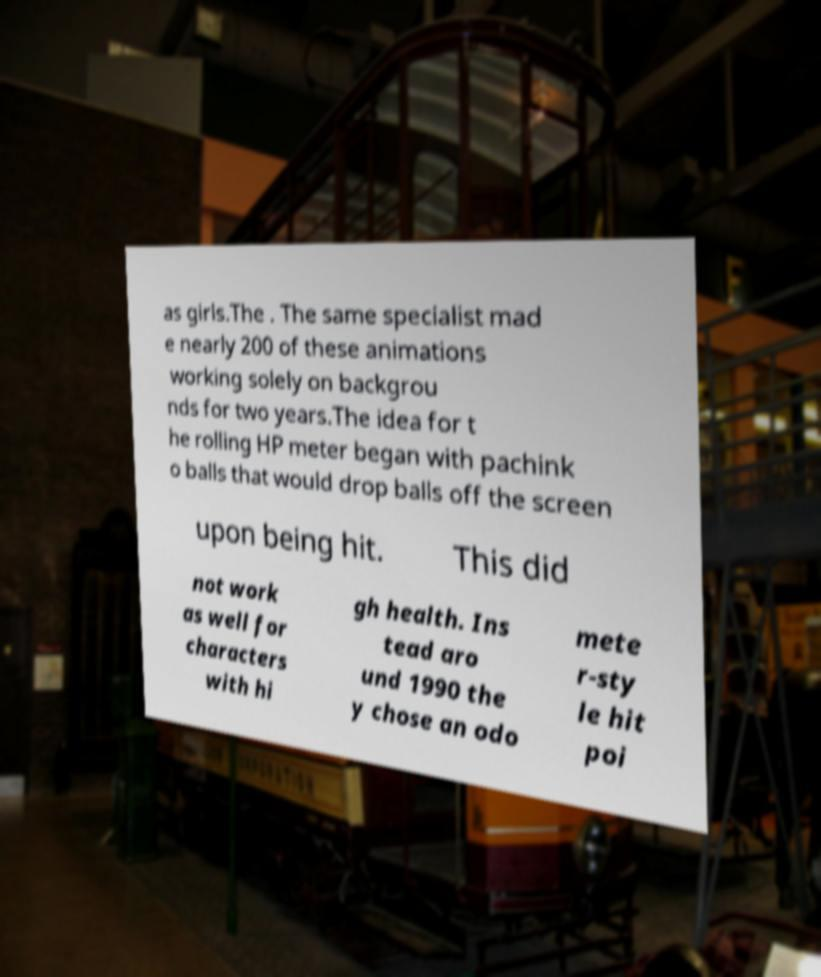What messages or text are displayed in this image? I need them in a readable, typed format. as girls.The . The same specialist mad e nearly 200 of these animations working solely on backgrou nds for two years.The idea for t he rolling HP meter began with pachink o balls that would drop balls off the screen upon being hit. This did not work as well for characters with hi gh health. Ins tead aro und 1990 the y chose an odo mete r-sty le hit poi 